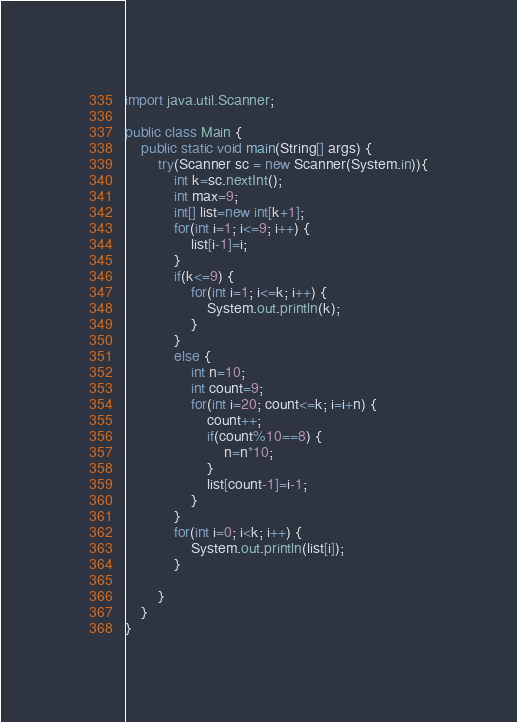Convert code to text. <code><loc_0><loc_0><loc_500><loc_500><_Java_>import java.util.Scanner;

public class Main {
	public static void main(String[] args) {
		try(Scanner sc = new Scanner(System.in)){
			int k=sc.nextInt();
			int max=9;
			int[] list=new int[k+1];
			for(int i=1; i<=9; i++) {
				list[i-1]=i;
			}
			if(k<=9) {
				for(int i=1; i<=k; i++) {
					System.out.println(k);
				}
			}
			else {
				int n=10;
				int count=9;
				for(int i=20; count<=k; i=i+n) {
					count++;
					if(count%10==8) {
						n=n*10;
					}
					list[count-1]=i-1;
				}
			}
			for(int i=0; i<k; i++) {
				System.out.println(list[i]);
			}
			
		}
	}
}</code> 